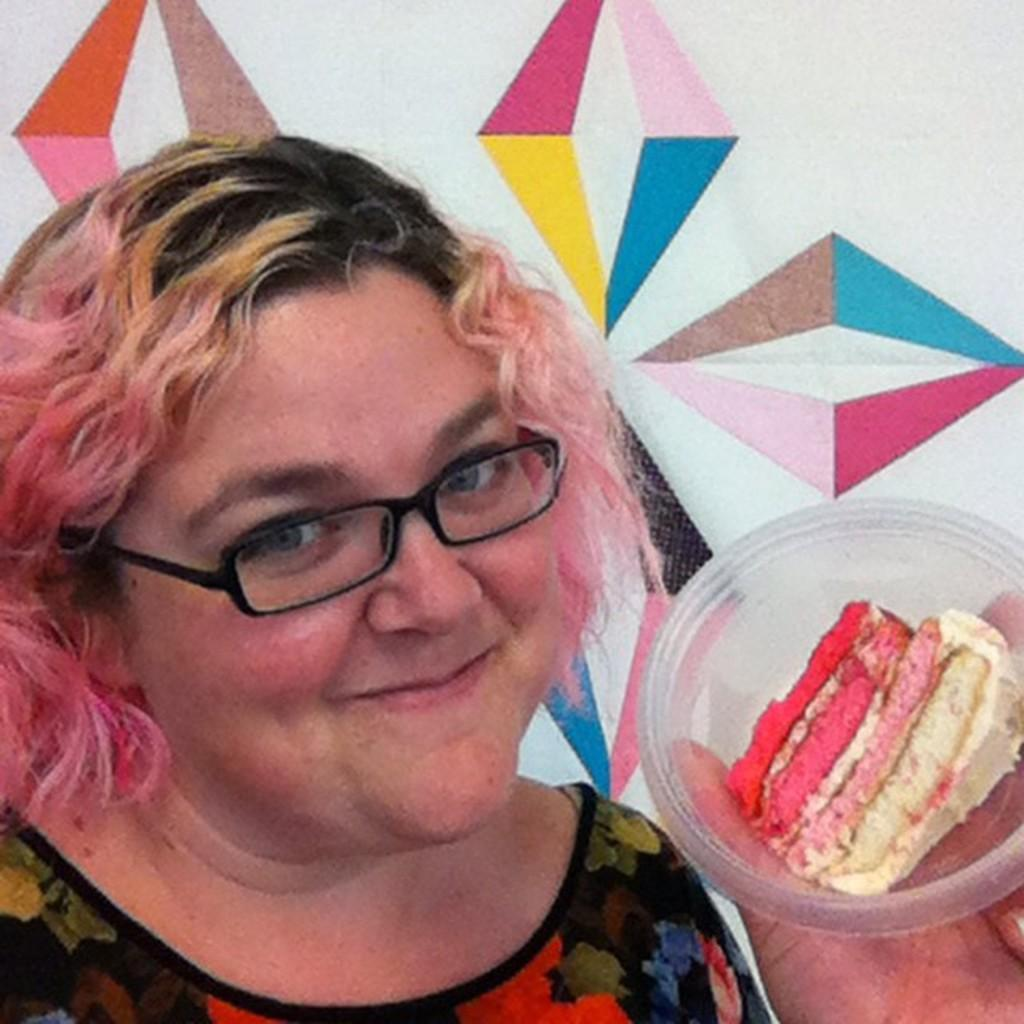Who is present in the image? There is a woman in the image. What is the woman holding in the image? The woman is holding a bowl. What is inside the bowl? There is: There is a piece of cake in the bowl. Can you describe the woman's appearance? The woman is wearing spectacles. What can be seen in the background of the image? There is a wall in the background of the image. What type of wrench is the woman using to fix the pump in the image? There is no wrench or pump present in the image; it features a woman holding a bowl with cake and wearing spectacles. 